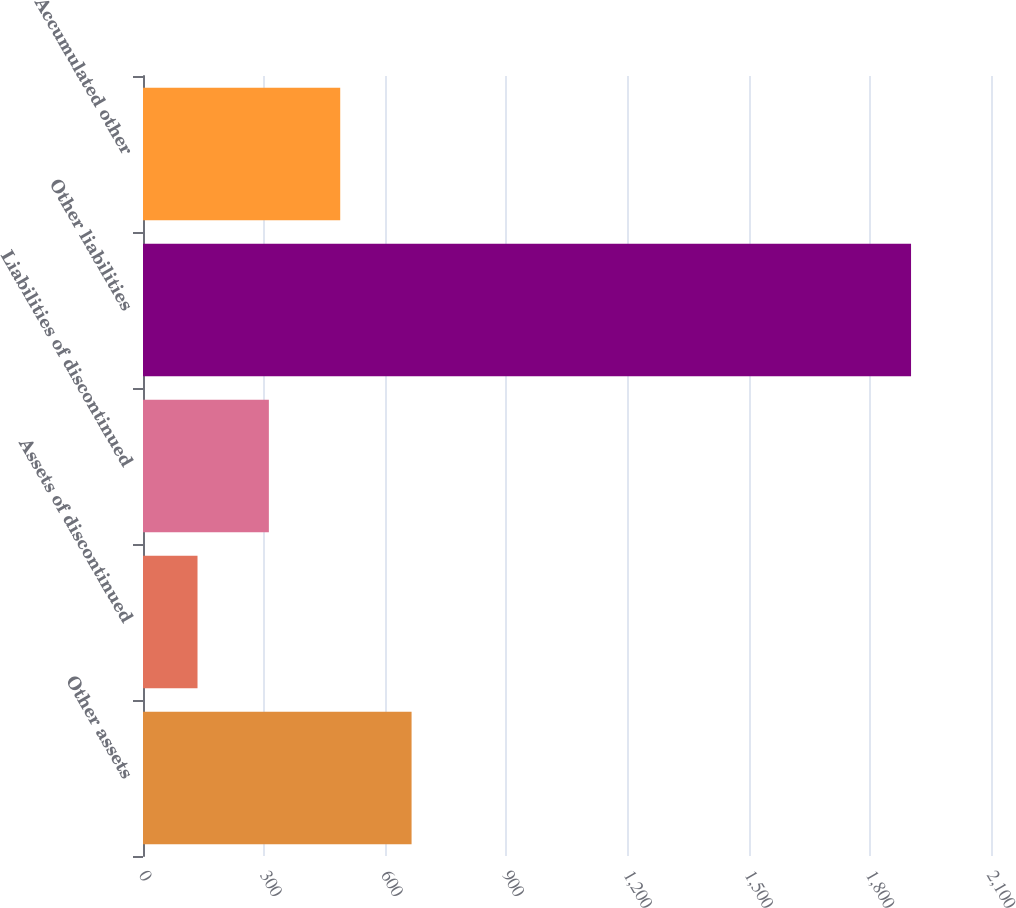<chart> <loc_0><loc_0><loc_500><loc_500><bar_chart><fcel>Other assets<fcel>Assets of discontinued<fcel>Liabilities of discontinued<fcel>Other liabilities<fcel>Accumulated other<nl><fcel>665.1<fcel>135<fcel>311.7<fcel>1902<fcel>488.4<nl></chart> 